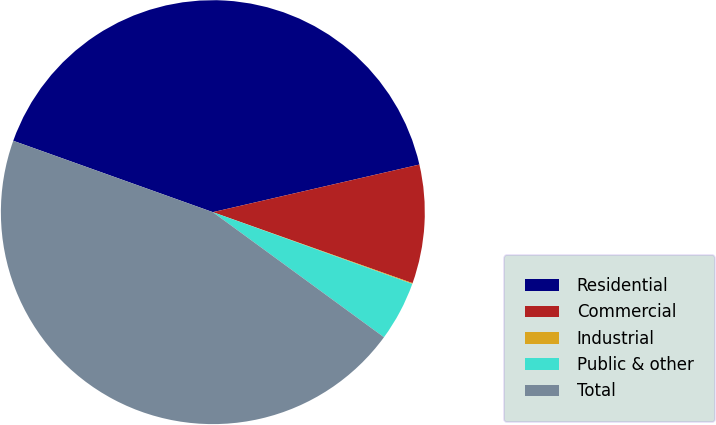Convert chart to OTSL. <chart><loc_0><loc_0><loc_500><loc_500><pie_chart><fcel>Residential<fcel>Commercial<fcel>Industrial<fcel>Public & other<fcel>Total<nl><fcel>40.93%<fcel>9.04%<fcel>0.06%<fcel>4.55%<fcel>45.42%<nl></chart> 